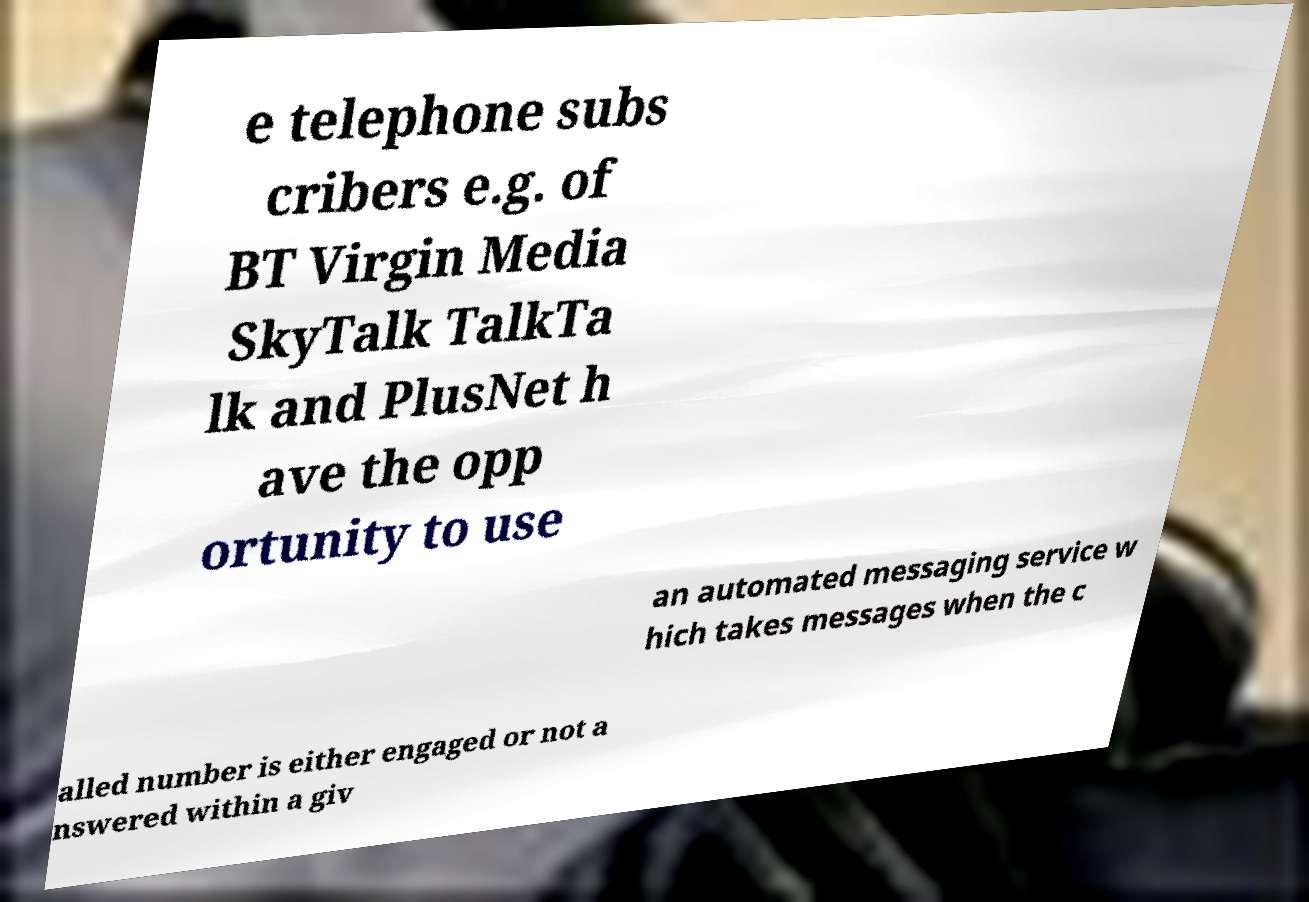Can you accurately transcribe the text from the provided image for me? e telephone subs cribers e.g. of BT Virgin Media SkyTalk TalkTa lk and PlusNet h ave the opp ortunity to use an automated messaging service w hich takes messages when the c alled number is either engaged or not a nswered within a giv 